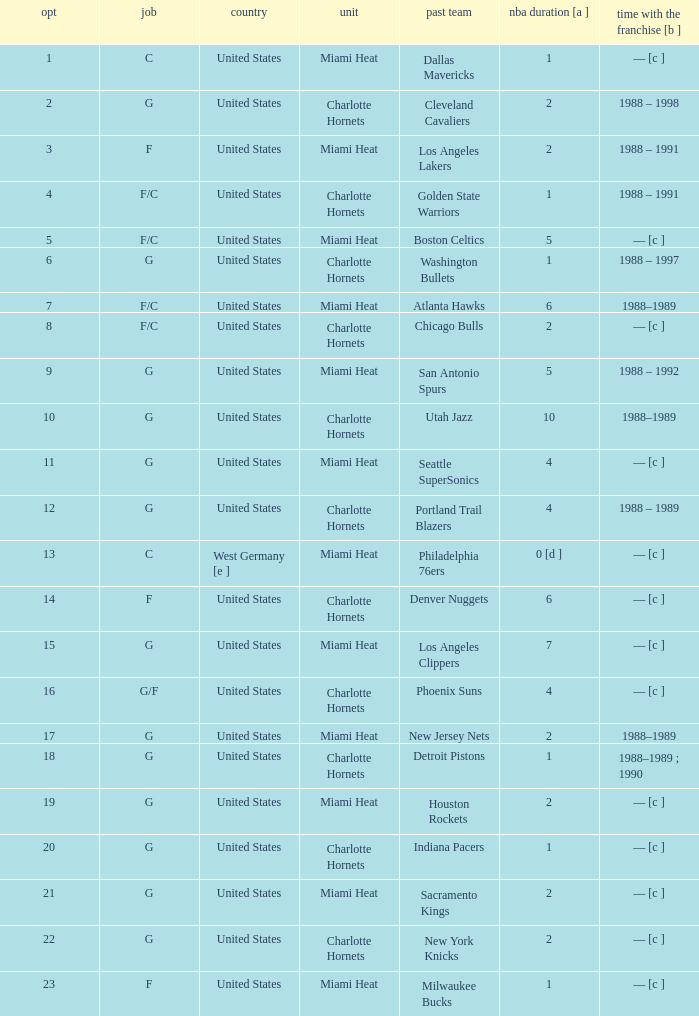What is the team of the player who was previously on the indiana pacers? Charlotte Hornets. 